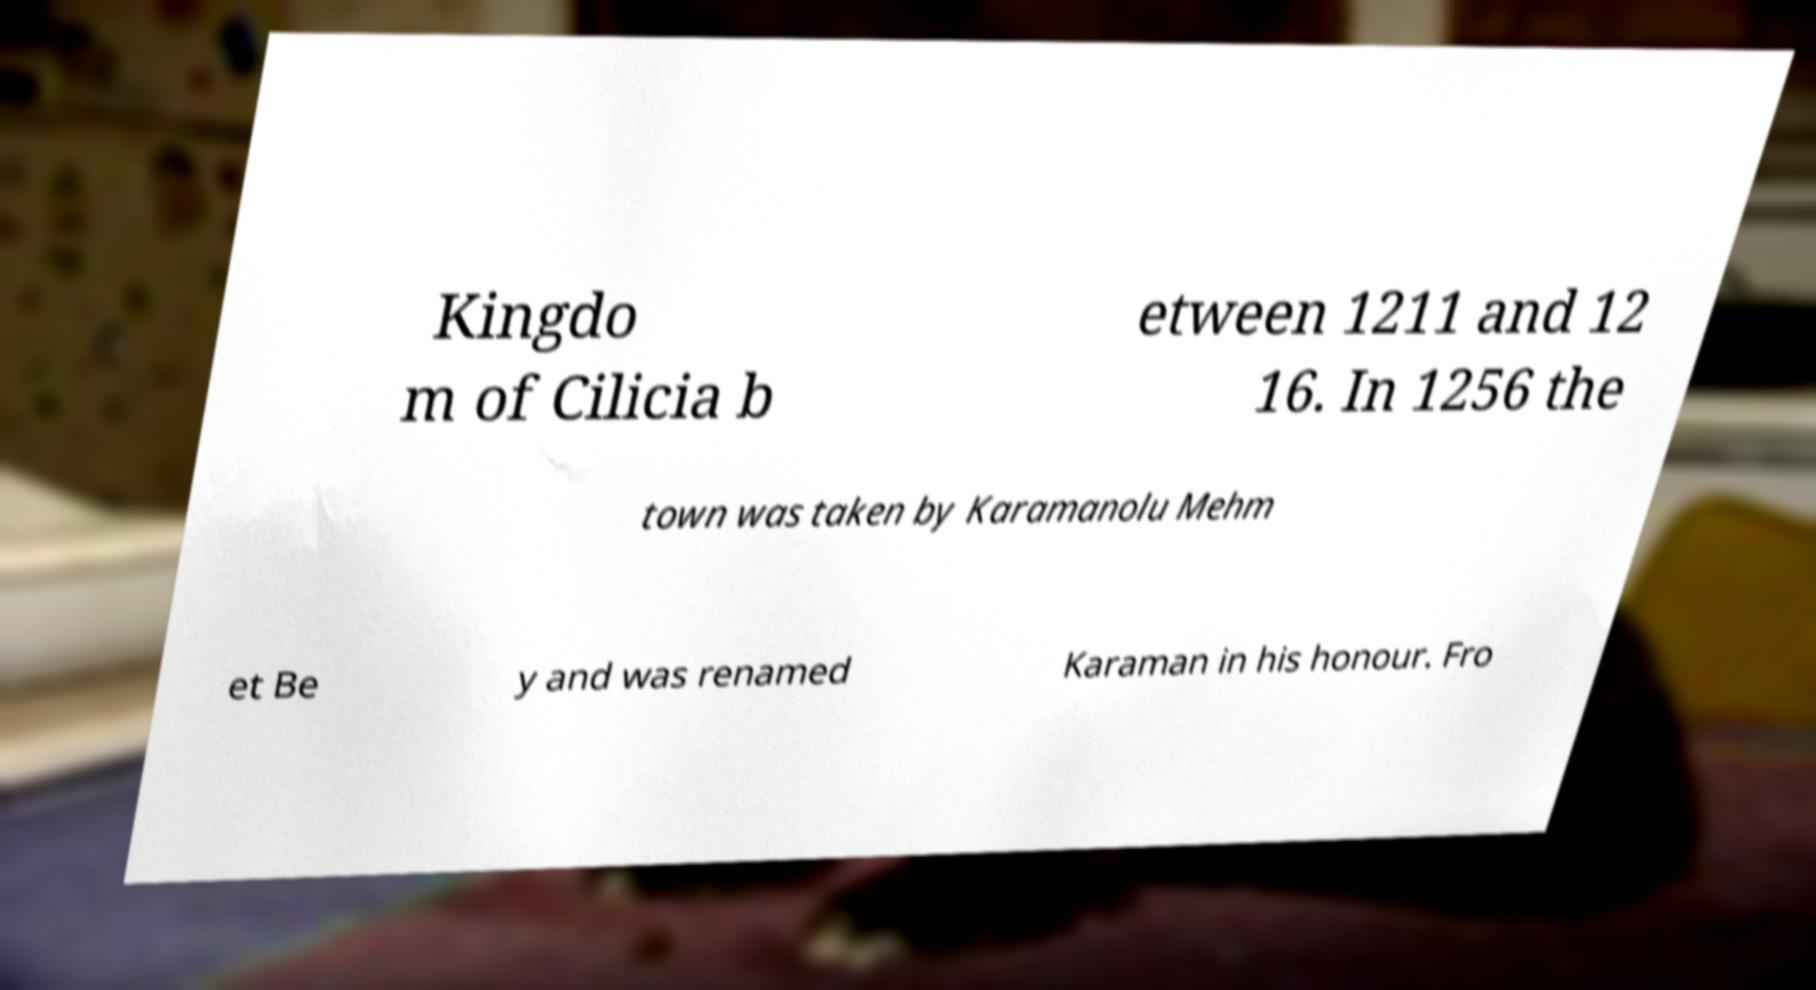For documentation purposes, I need the text within this image transcribed. Could you provide that? Kingdo m of Cilicia b etween 1211 and 12 16. In 1256 the town was taken by Karamanolu Mehm et Be y and was renamed Karaman in his honour. Fro 